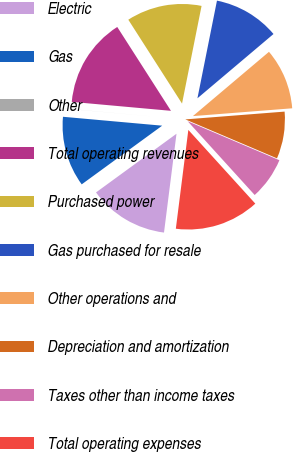Convert chart to OTSL. <chart><loc_0><loc_0><loc_500><loc_500><pie_chart><fcel>Electric<fcel>Gas<fcel>Other<fcel>Total operating revenues<fcel>Purchased power<fcel>Gas purchased for resale<fcel>Other operations and<fcel>Depreciation and amortization<fcel>Taxes other than income taxes<fcel>Total operating expenses<nl><fcel>12.97%<fcel>11.45%<fcel>0.01%<fcel>14.5%<fcel>12.21%<fcel>10.69%<fcel>9.92%<fcel>7.64%<fcel>6.87%<fcel>13.74%<nl></chart> 